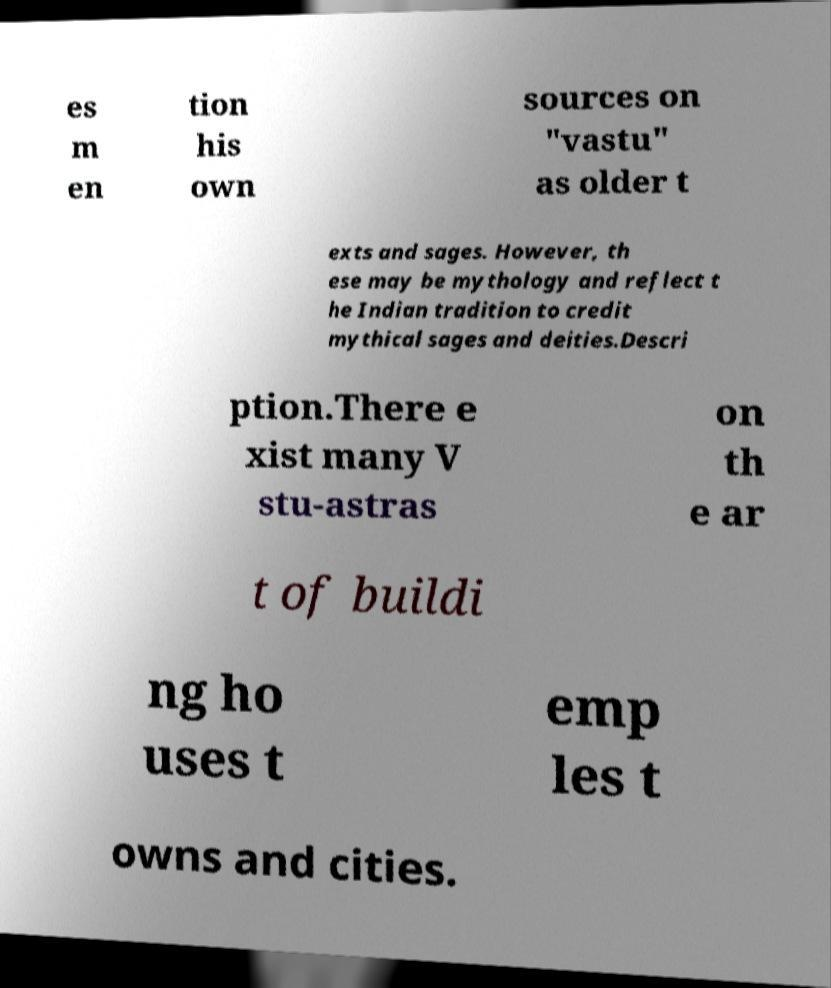Please read and relay the text visible in this image. What does it say? es m en tion his own sources on "vastu" as older t exts and sages. However, th ese may be mythology and reflect t he Indian tradition to credit mythical sages and deities.Descri ption.There e xist many V stu-astras on th e ar t of buildi ng ho uses t emp les t owns and cities. 